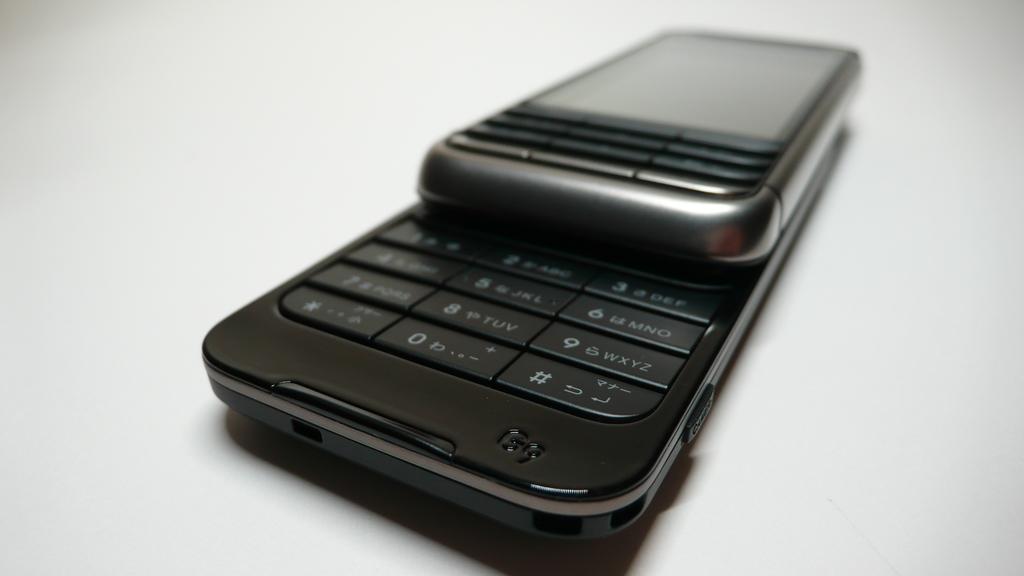What is shown on number 5?
Give a very brief answer. Jkl. 